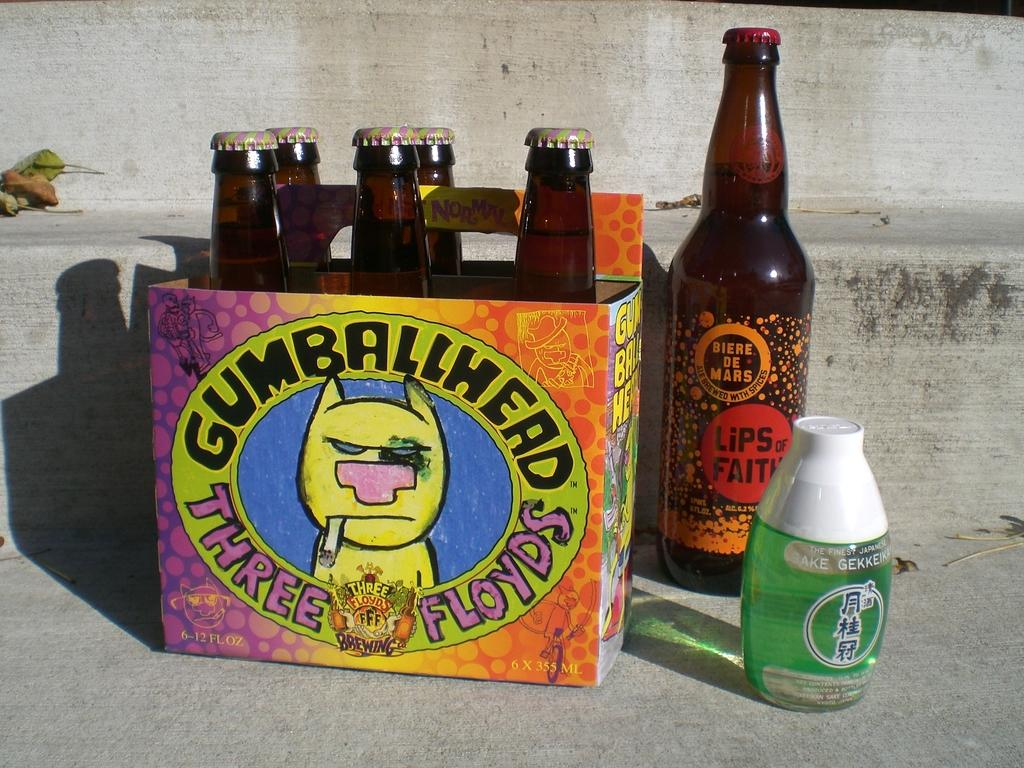<image>
Describe the image concisely. a pack of six bottles labeled 'gumballhead three floyds' 